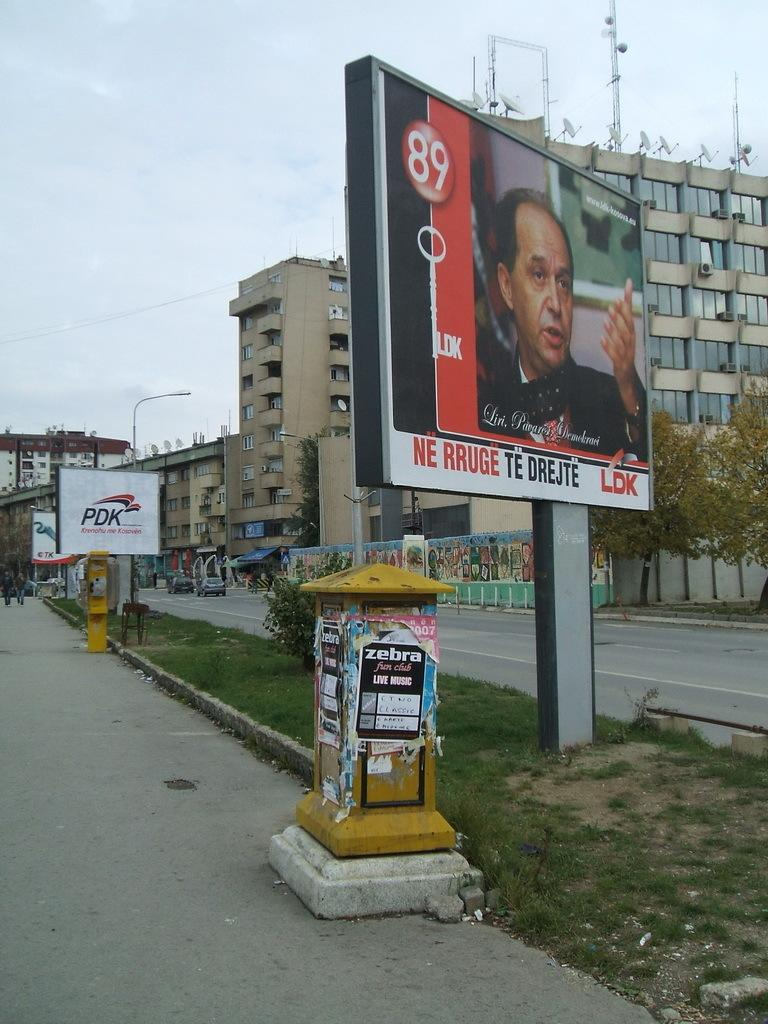Provide a one-sentence caption for the provided image. The billboard shows a man and it says "NE RRUGE TE DREJTE". 